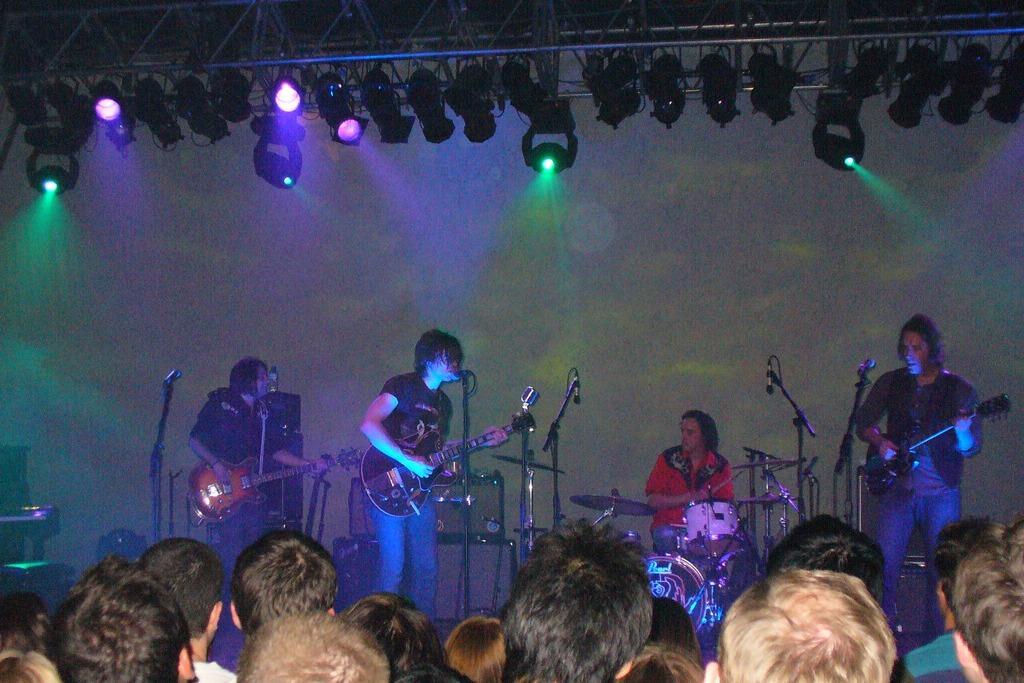Can you describe this image briefly? There are three people in playing guitar and singing in front of mike and the person in the background is playing drums and there are audience in front of them. 